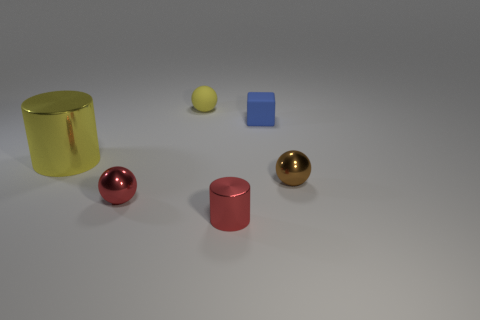There is a small ball behind the large object; is it the same color as the shiny cylinder on the left side of the red cylinder?
Offer a terse response. Yes. What material is the yellow sphere that is the same size as the red cylinder?
Offer a very short reply. Rubber. There is a cylinder that is left of the yellow thing on the right side of the small red shiny object that is behind the small red cylinder; what size is it?
Your response must be concise. Large. How many other things are the same material as the blue thing?
Provide a short and direct response. 1. There is a shiny cylinder behind the brown metallic ball; what is its size?
Give a very brief answer. Large. What number of spheres are both behind the large shiny cylinder and in front of the large yellow metal object?
Your answer should be compact. 0. The yellow thing that is behind the shiny thing that is behind the small brown ball is made of what material?
Your answer should be very brief. Rubber. There is a small yellow object that is the same shape as the tiny brown thing; what material is it?
Your answer should be very brief. Rubber. Are there any blue blocks?
Your response must be concise. Yes. The yellow thing that is the same material as the blue cube is what shape?
Your answer should be compact. Sphere. 